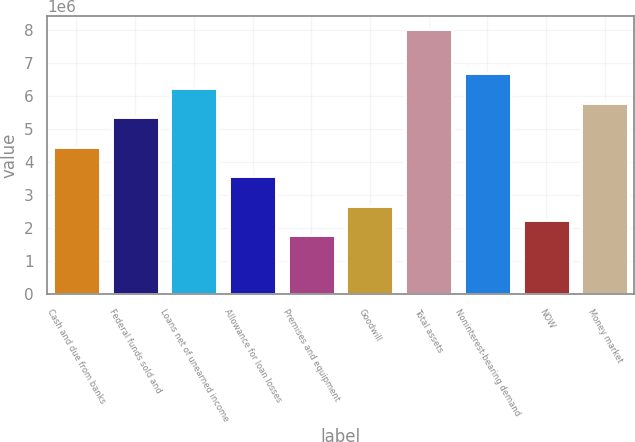<chart> <loc_0><loc_0><loc_500><loc_500><bar_chart><fcel>Cash and due from banks<fcel>Federal funds sold and<fcel>Loans net of unearned income<fcel>Allowance for loan losses<fcel>Premises and equipment<fcel>Goodwill<fcel>Total assets<fcel>Noninterest-bearing demand<fcel>NOW<fcel>Money market<nl><fcel>4.46537e+06<fcel>5.35844e+06<fcel>6.2515e+06<fcel>3.5723e+06<fcel>1.78617e+06<fcel>2.67924e+06<fcel>8.03764e+06<fcel>6.69804e+06<fcel>2.2327e+06<fcel>5.80497e+06<nl></chart> 